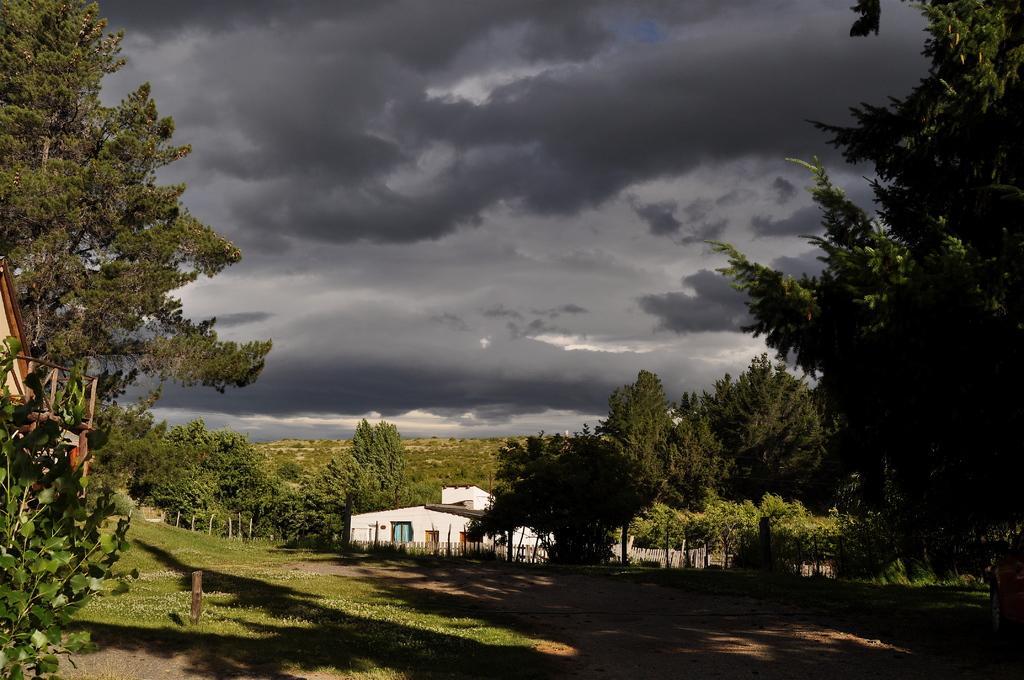Describe this image in one or two sentences. In this image, I can see a house and the trees. In the background, there is the cloudy sky. At the bottom of the image, I can see the grass. 